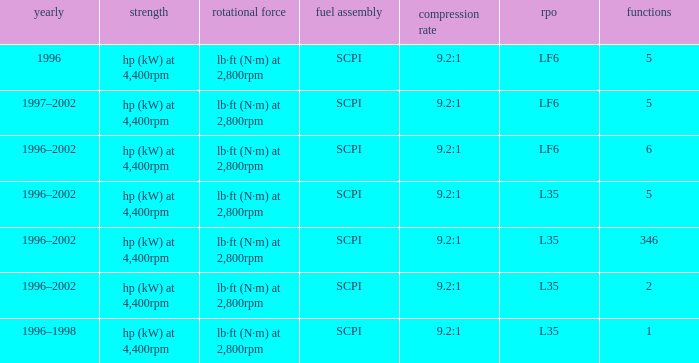What are the torque characteristics of the model with 346 applications? Lb·ft (n·m) at 2,800rpm. I'm looking to parse the entire table for insights. Could you assist me with that? {'header': ['yearly', 'strength', 'rotational force', 'fuel assembly', 'compression rate', 'rpo', 'functions'], 'rows': [['1996', 'hp (kW) at 4,400rpm', 'lb·ft (N·m) at 2,800rpm', 'SCPI', '9.2:1', 'LF6', '5'], ['1997–2002', 'hp (kW) at 4,400rpm', 'lb·ft (N·m) at 2,800rpm', 'SCPI', '9.2:1', 'LF6', '5'], ['1996–2002', 'hp (kW) at 4,400rpm', 'lb·ft (N·m) at 2,800rpm', 'SCPI', '9.2:1', 'LF6', '6'], ['1996–2002', 'hp (kW) at 4,400rpm', 'lb·ft (N·m) at 2,800rpm', 'SCPI', '9.2:1', 'L35', '5'], ['1996–2002', 'hp (kW) at 4,400rpm', 'lb·ft (N·m) at 2,800rpm', 'SCPI', '9.2:1', 'L35', '346'], ['1996–2002', 'hp (kW) at 4,400rpm', 'lb·ft (N·m) at 2,800rpm', 'SCPI', '9.2:1', 'L35', '2'], ['1996–1998', 'hp (kW) at 4,400rpm', 'lb·ft (N·m) at 2,800rpm', 'SCPI', '9.2:1', 'L35', '1']]} 